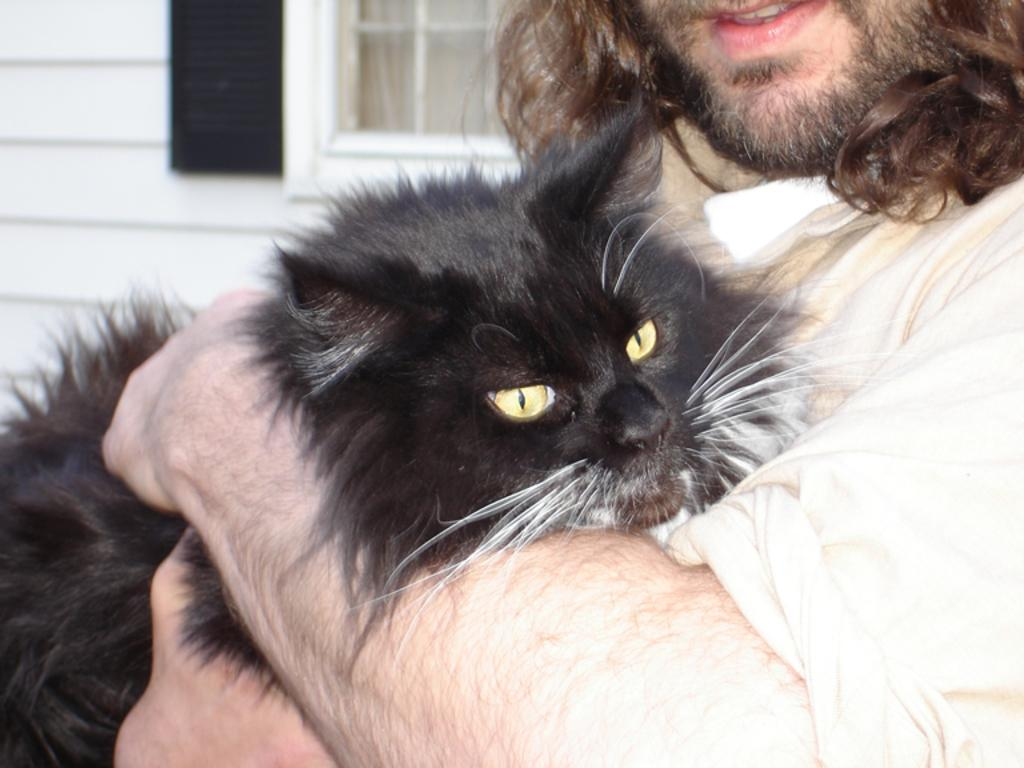What can be seen in the image? There is a person in the image. What is the person wearing? The person is wearing a shirt. What is the person holding in the image? The person is holding a black cat. What is visible in the background of the image? There is a house in the background of the image. What features can be observed about the house? The house has a window and a curtain associated with the window. What type of legal advice is the person providing in the image? There is no indication in the image that the person is providing legal advice or is a lawyer. 